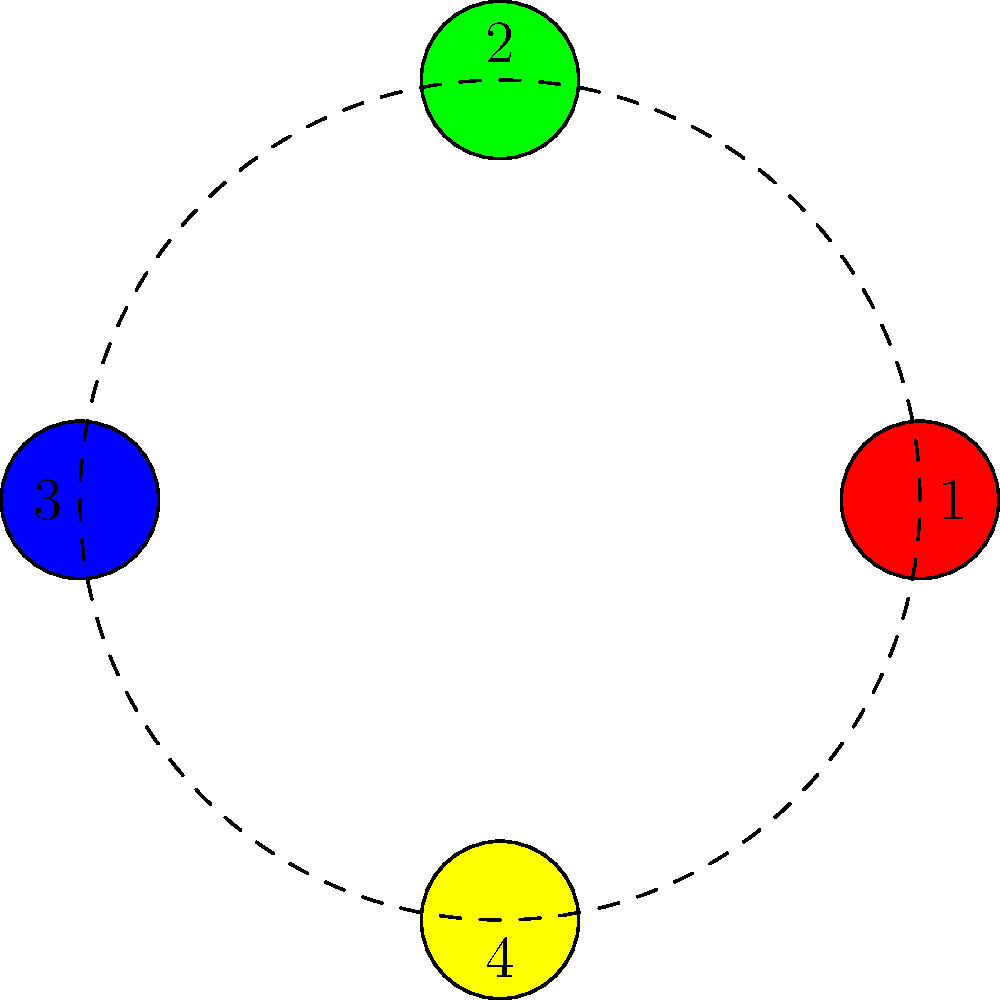As a fireworks manufacturer, you're arranging a circular display with four unique colored fireworks: red, green, blue, and yellow. The display can be rotated, but the relative positions of the fireworks remain fixed. How many distinct arrangements are possible considering rotational symmetry? To solve this problem, we need to consider the properties of cyclic permutation groups:

1. We have 4 distinct colors, so without considering rotational symmetry, there would be $4! = 24$ possible arrangements.

2. However, due to the circular nature of the display and rotational symmetry, some of these arrangements are equivalent.

3. In a circular arrangement with 4 elements, there are 4 possible rotations that return the arrangement to its original state (including the identity rotation).

4. This means that each unique arrangement has 4 equivalent rotations.

5. To find the number of distinct arrangements, we need to divide the total number of permutations by the number of rotations:

   $\text{Number of distinct arrangements} = \frac{\text{Total permutations}}{\text{Number of rotations}} = \frac{4!}{4} = \frac{24}{4} = 6$

Therefore, there are 6 distinct arrangements possible for the circular fireworks display when considering rotational symmetry.
Answer: 6 distinct arrangements 